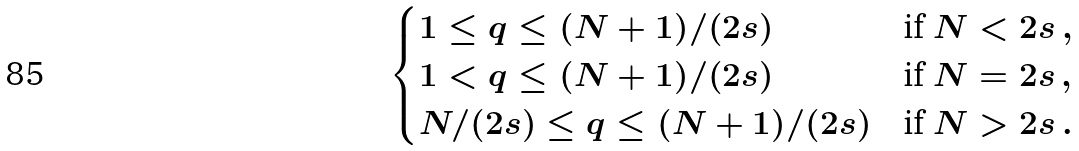<formula> <loc_0><loc_0><loc_500><loc_500>\begin{cases} 1 \leq q \leq ( N + 1 ) / ( 2 s ) & \text {if} \ N < 2 s \, , \\ 1 < q \leq ( N + 1 ) / ( 2 s ) & \text {if} \ N = 2 s \, , \\ N / ( 2 s ) \leq q \leq ( N + 1 ) / ( 2 s ) & \text {if} \ N > 2 s \, . \end{cases}</formula> 